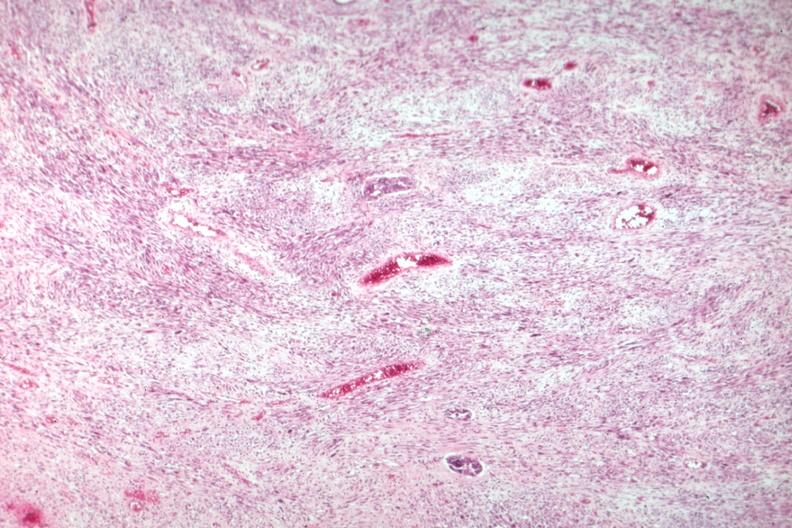where is this from?
Answer the question using a single word or phrase. Female reproductive system 